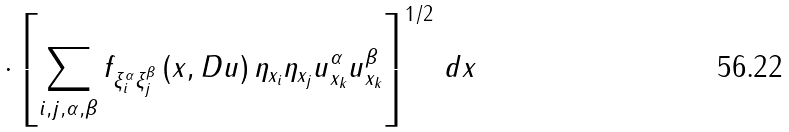Convert formula to latex. <formula><loc_0><loc_0><loc_500><loc_500>\cdot \left [ \sum _ { i , j , \alpha , \beta } f _ { \xi _ { i } ^ { \alpha } \xi _ { j } ^ { \beta } } \left ( x , D u \right ) \eta _ { x _ { i } } \eta _ { x _ { j } } u _ { x _ { k } } ^ { \alpha } u _ { x _ { k } } ^ { \beta } \right ] ^ { 1 / 2 } \, d x</formula> 